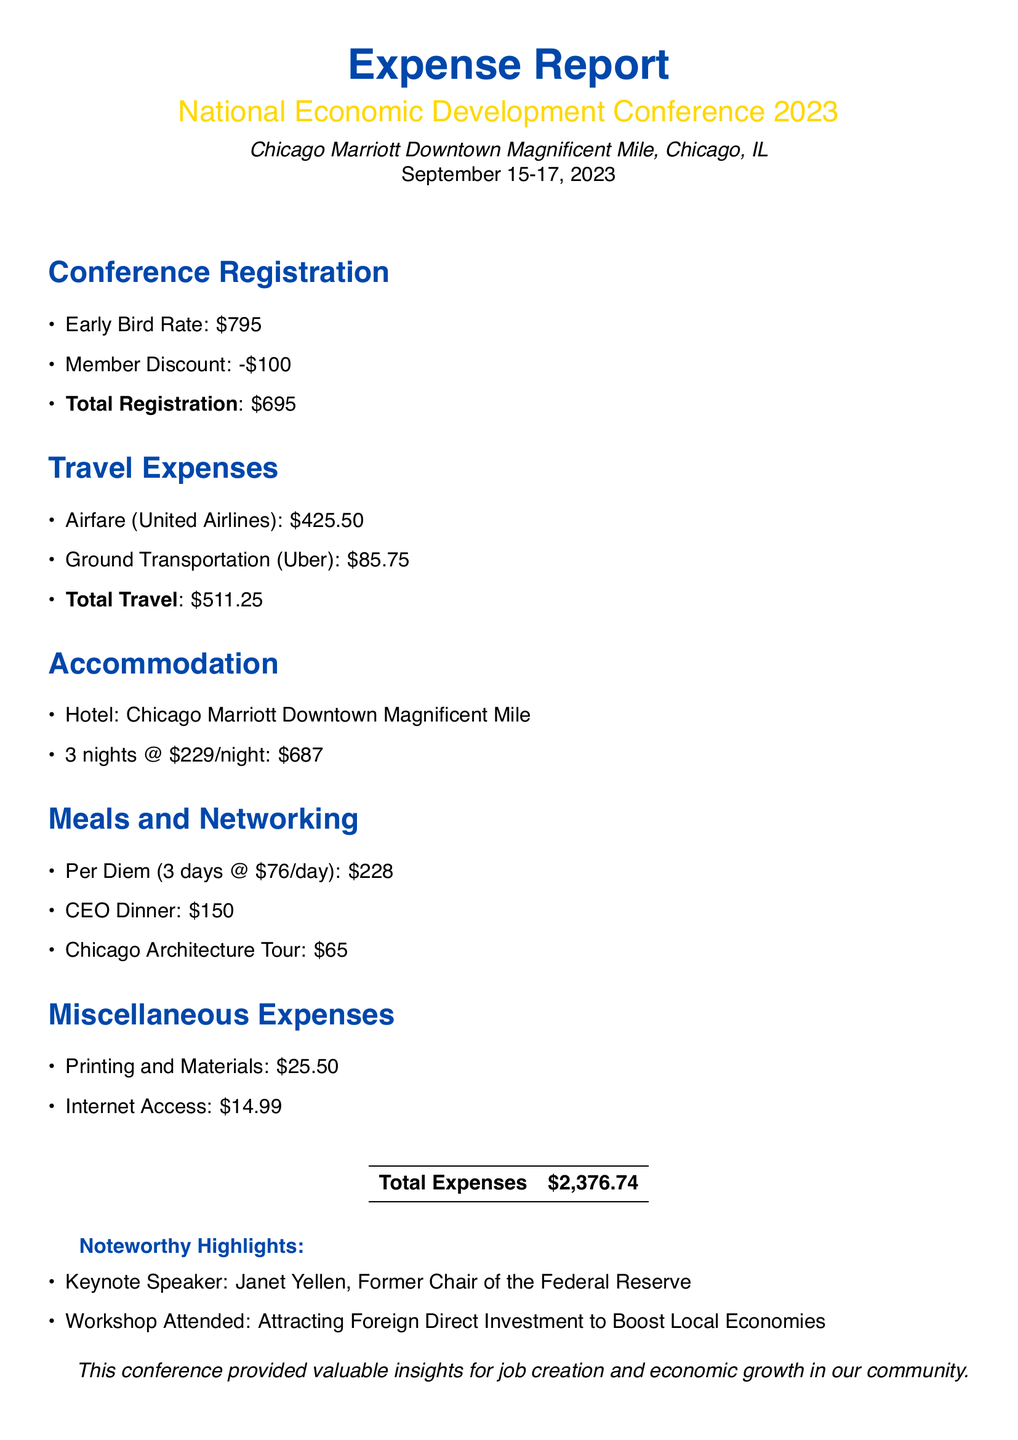What is the total registration fee? The total registration fee includes the early bird rate of $795 and a member discount of $100.
Answer: $695 What is the airfare cost? The document lists airfare specifically for United Airlines at $425.50.
Answer: $425.50 How many nights was the accommodation for? The accommodation section states that the hotel was for 3 nights.
Answer: 3 nights What is the per diem amount for meals? The per diem for meals is given as $76 per day for 3 days, calculated as $228.
Answer: $228 Who was the keynote speaker? The document mentions Janet Yellen as the keynote speaker.
Answer: Janet Yellen What was the total cost of miscellaneous expenses? The total for miscellaneous expenses includes printing and internet access, totaling $40.49.
Answer: $40.49 What was the total expense reported? The total expenses added up from different sections of the report give a total of $2,376.74.
Answer: $2,376.74 What city hosted the conference? The document states that the conference took place in Chicago, IL.
Answer: Chicago What was the name of the hotel? The hotel mentioned for accommodation is the Chicago Marriott Downtown Magnificent Mile.
Answer: Chicago Marriott Downtown Magnificent Mile 